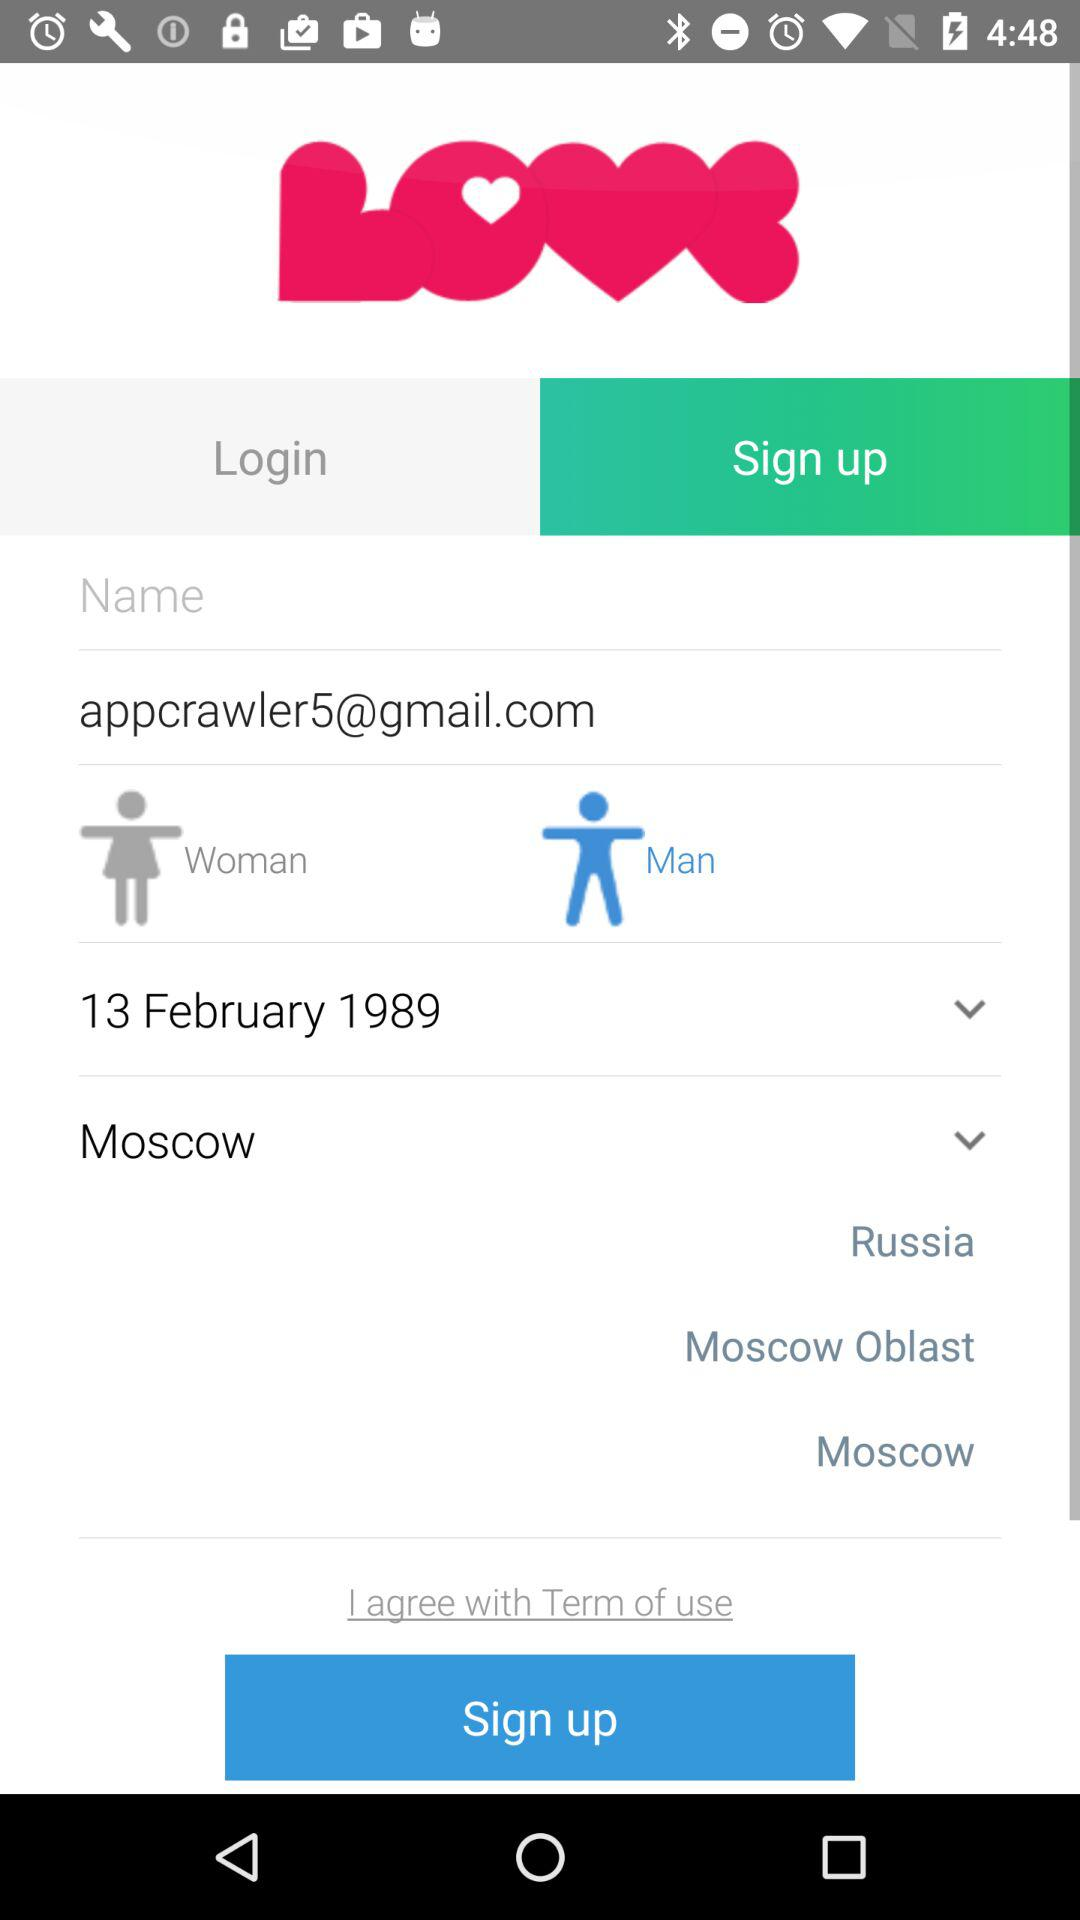What are the different options of the country? The different options are "Russia", "Moscow Oblast", and "Moscow". 